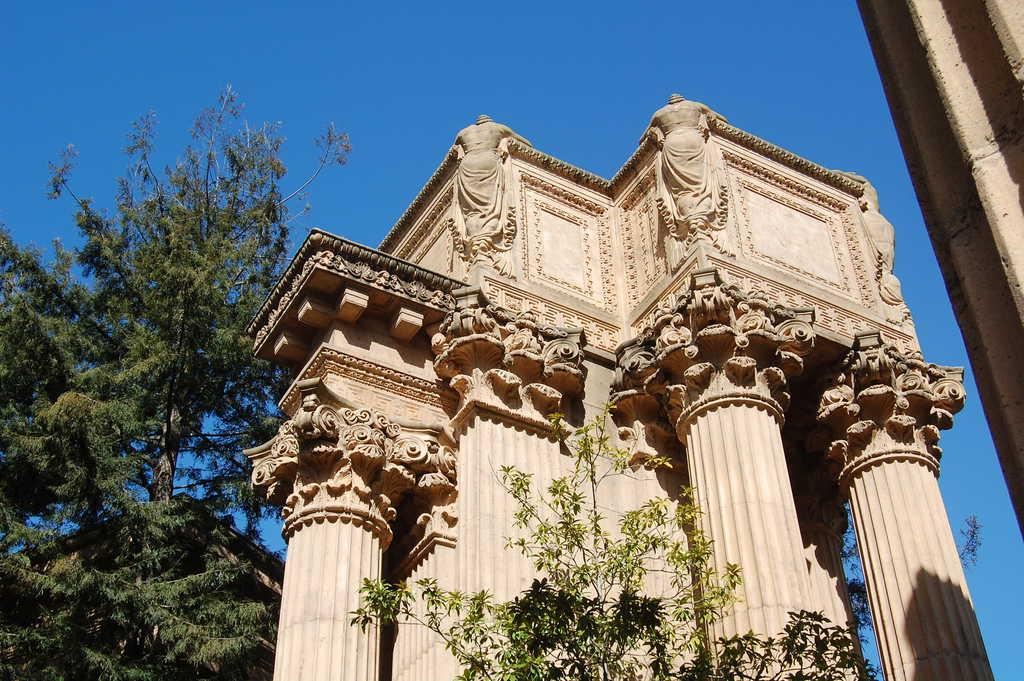What type of natural elements can be seen in the image? There are trees in the image. What type of man-made structure is in the foreground of the image? There is a building in the foreground of the image. What type of artistic objects are present in the image? There are sculptures in the image. What type of decorative design can be seen on a wall in the image? There is a floral design on a wall in the image. What is visible at the top of the image? The sky is visible at the top of the image. Can you tell me how many buttons are on the finger of the person in the image? There is no person present in the image, and therefore no fingers or buttons can be observed. 